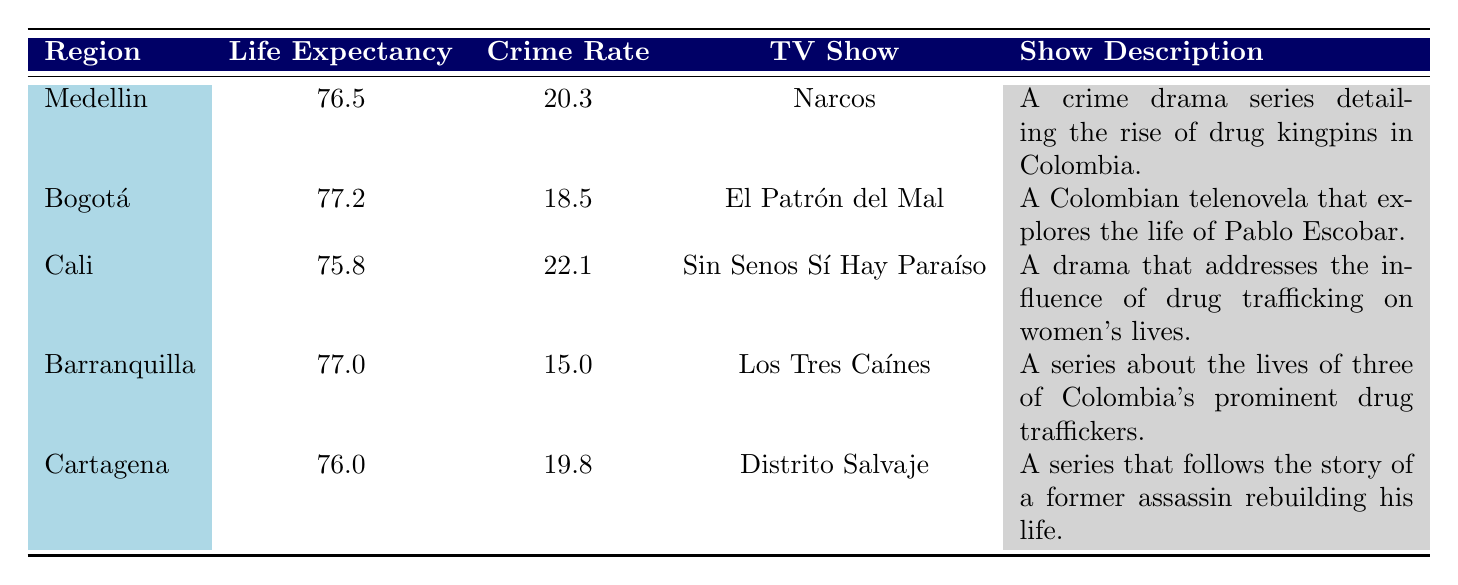What is the average life expectancy in Bogotá? The table shows that Bogotá has an average life expectancy of 77.2 years.
Answer: 77.2 Which TV show is associated with the highest crime rate? Looking at the table, Cali has the highest crime rate of 22.1 and it is associated with the TV show "Sin Senos Sí Hay Paraíso."
Answer: Sin Senos Sí Hay Paraíso Is the average life expectancy in Barranquilla greater than that in Cali? The table lists Barranquilla's life expectancy as 77.0 and Cali's as 75.8. Since 77.0 is greater than 75.8, the statement is true.
Answer: Yes What is the difference in crime rates between Medellin and Cartagena? The crime rate in Medellin is 20.3, and in Cartagena, it is 19.8. The difference is calculated as 20.3 - 19.8 = 0.5.
Answer: 0.5 Which region has a crime rate lower than 20? Barranquilla has a crime rate of 15.0, which is lower than 20. The table shows it's the only region under that threshold.
Answer: Barranquilla What is the average life expectancy of the regions covered in the table? To find the average, we add all the life expectancies: 76.5 + 77.2 + 75.8 + 77.0 + 76.0 = 382.5. Then we divide by the number of regions, which is 5. Therefore, 382.5 / 5 = 76.5.
Answer: 76.5 Is "El Patrón del Mal" present in the region with the highest life expectancy? The region with the highest life expectancy is Bogotá at 77.2 years, which is indeed where "El Patrón del Mal" is set. Thus, this statement is true.
Answer: Yes Which TV show depicts a story about a woman’s life influenced by drug trafficking and where is it set? The show "Sin Senos Sí Hay Paraíso" depicts a woman's life influenced by drug trafficking and is set in Cali.
Answer: Sin Senos Sí Hay Paraíso in Cali 